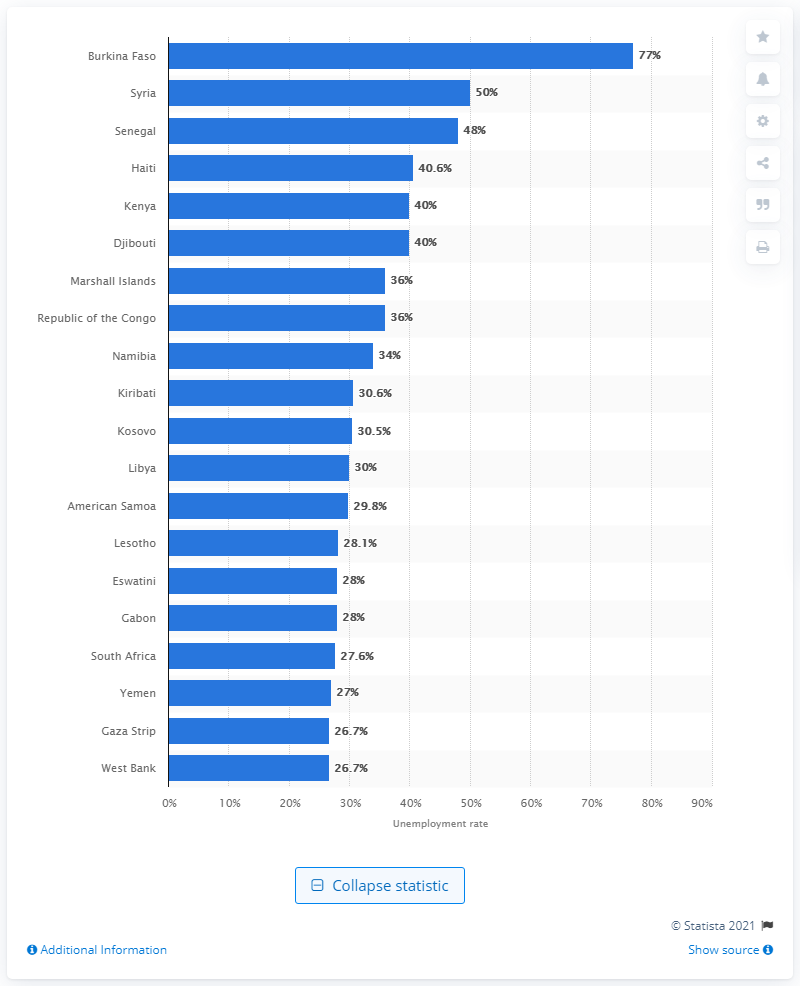Mention a couple of crucial points in this snapshot. Burkina Faso had the highest unemployment rate in the world in 2017. 